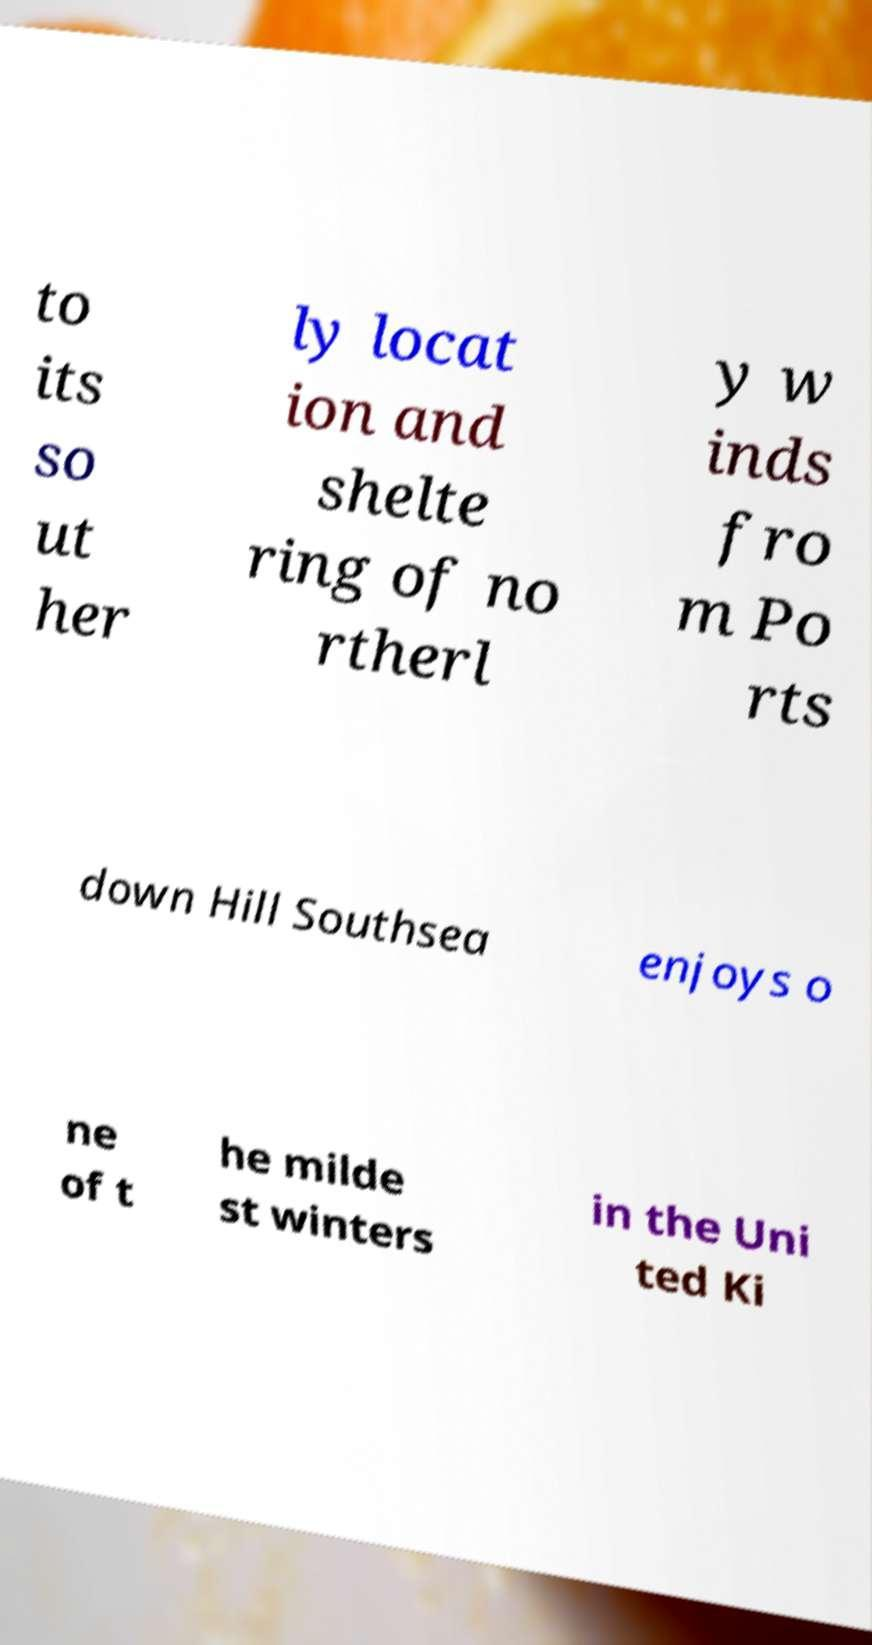For documentation purposes, I need the text within this image transcribed. Could you provide that? to its so ut her ly locat ion and shelte ring of no rtherl y w inds fro m Po rts down Hill Southsea enjoys o ne of t he milde st winters in the Uni ted Ki 